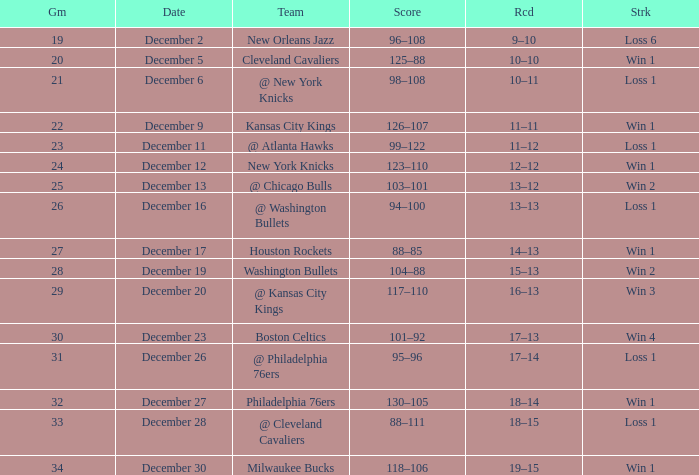What is the Streak on December 30? Win 1. 